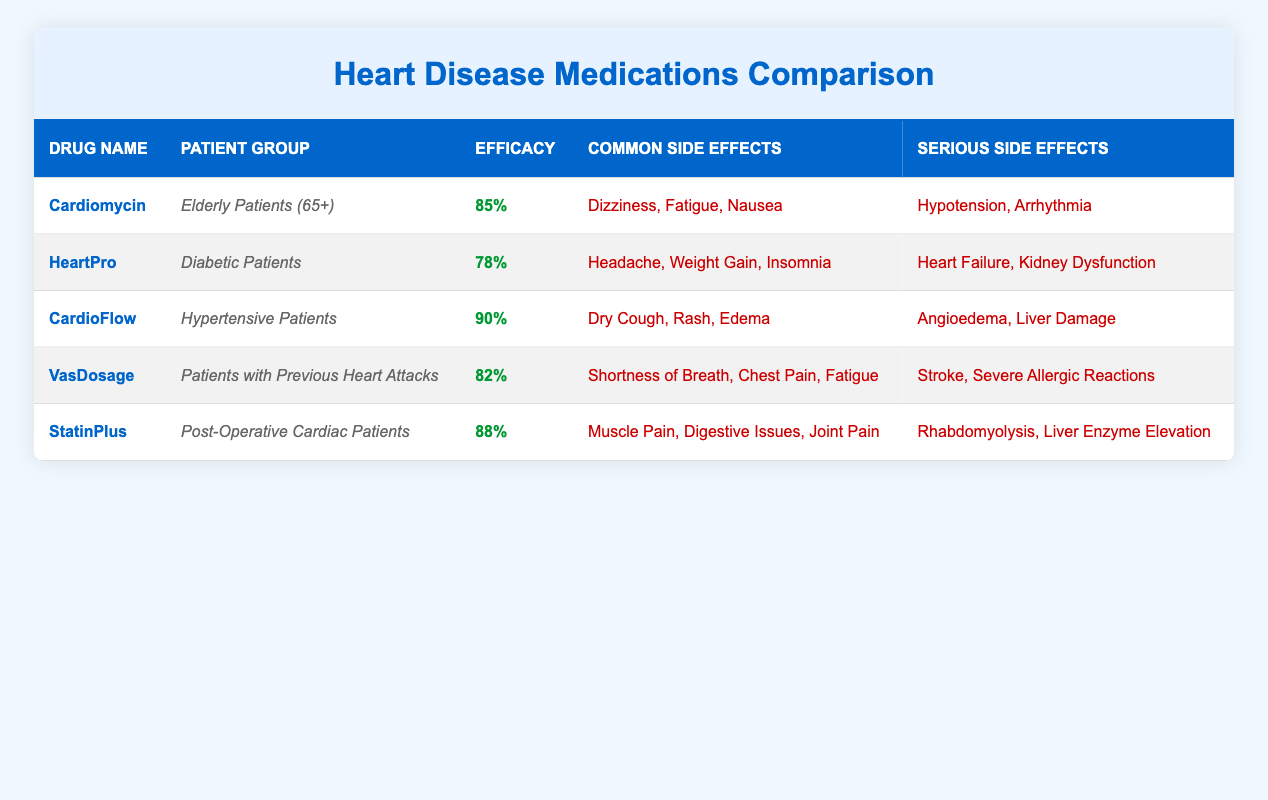What is the efficacy percentage of CardioFlow for hypertensive patients? The table lists "CardioFlow" under the drug name, with the corresponding efficacy percentage of "90%" for the patient group of "Hypertensive Patients".
Answer: 90% Which drug has the most common side effects listed? By reviewing the common side effects for each drug, "CardioFlow," "VasDosage," and "HeartPro" each have three common side effects listed, making them tied for the most.
Answer: Cardiomycin, VasDosage, HeartPro Do elderly patients experience any serious side effects when taking Cardiomycin? The table states that "Cardiomycin" can result in serious side effects such as "Hypotension" and "Arrhythmia" for elderly patients (65+). Therefore, yes, they do experience serious side effects.
Answer: Yes What is the difference in efficacy percentage between StatinPlus and HeartPro? StatinPlus has an efficacy of "88%", while HeartPro has an efficacy of "78%". The difference can be calculated as follows: 88% - 78% = 10%.
Answer: 10% For which patient group is the drug HeartPro specifically designed? According to the table, the drug "HeartPro" is specifically designed for "Diabetic Patients."
Answer: Diabetic Patients Is it true that the drug VasDosage has muscle pain as a common side effect? Upon checking the side effects listed for VasDosage, the common side effects include "Shortness of Breath," "Chest Pain," and "Fatigue," but not "Muscle Pain." Therefore, the statement is false.
Answer: No What is the average efficacy percentage of all heart disease medications listed? To find the average efficacy percentage, sum up the efficacy percentages (85 + 78 + 90 + 82 + 88 = 423) and divide by the number of medications (5): 423 / 5 = 84.6%.
Answer: 84.6% Which drug has the highest percentage of efficacy and what patient group does it serve? The highest efficacy percentage is 90%, which belongs to "CardioFlow," serving the patient group of "Hypertensive Patients."
Answer: CardioFlow, Hypertensive Patients How many serious side effects does StatinPlus have compared to HeartPro? StatinPlus has two serious side effects listed: "Rhabdomyolysis" and "Liver Enzyme Elevation." HeartPro also has two serious side effects: "Heart Failure" and "Kidney Dysfunction." The comparison shows they both have the same number of serious side effects.
Answer: Both have 2 serious side effects 